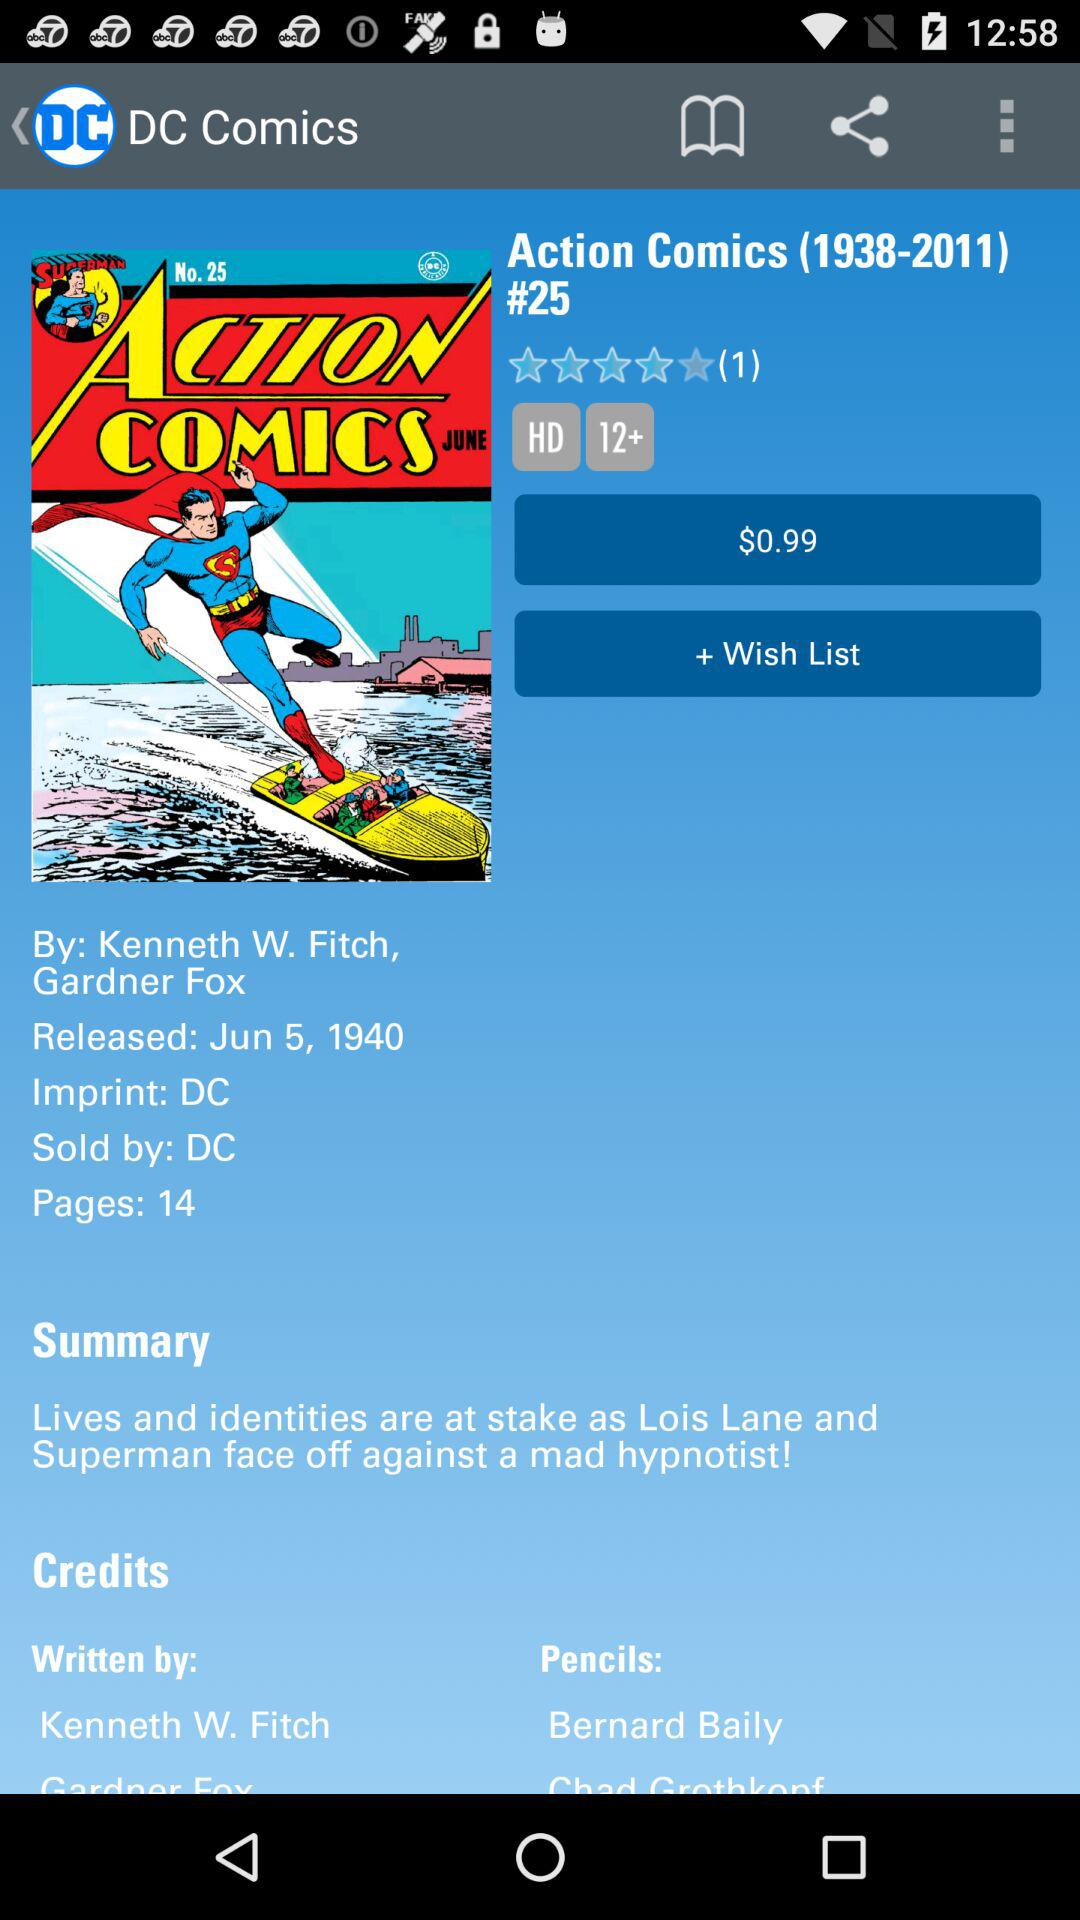How many pages are in this comic?
Answer the question using a single word or phrase. 14 